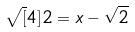<formula> <loc_0><loc_0><loc_500><loc_500>\sqrt { [ } 4 ] { 2 } = x - \sqrt { 2 }</formula> 